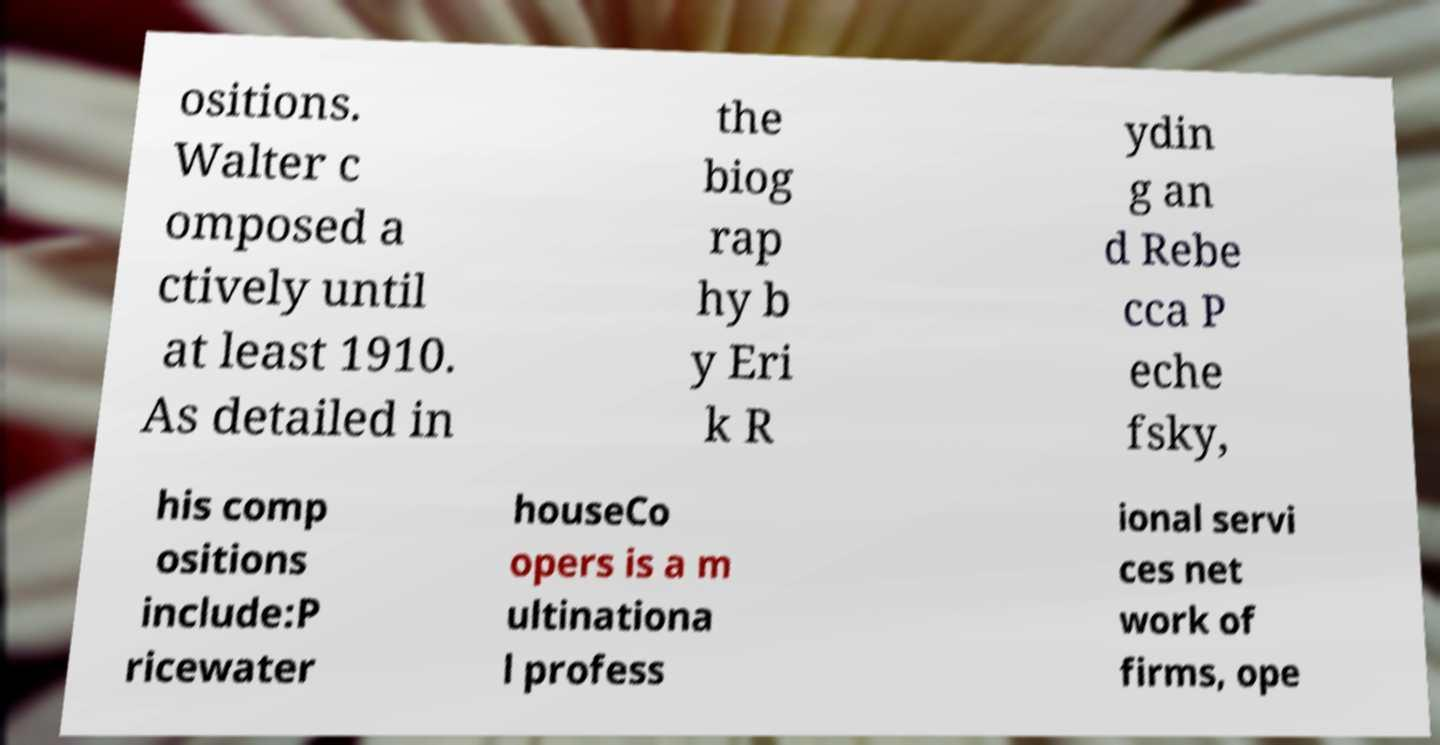There's text embedded in this image that I need extracted. Can you transcribe it verbatim? ositions. Walter c omposed a ctively until at least 1910. As detailed in the biog rap hy b y Eri k R ydin g an d Rebe cca P eche fsky, his comp ositions include:P ricewater houseCo opers is a m ultinationa l profess ional servi ces net work of firms, ope 